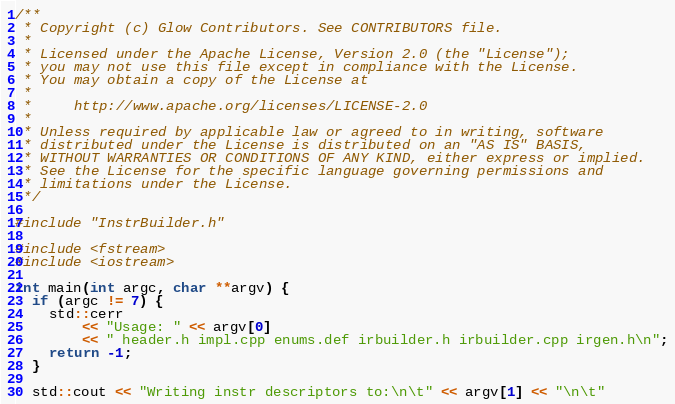Convert code to text. <code><loc_0><loc_0><loc_500><loc_500><_C++_>/**
 * Copyright (c) Glow Contributors. See CONTRIBUTORS file.
 *
 * Licensed under the Apache License, Version 2.0 (the "License");
 * you may not use this file except in compliance with the License.
 * You may obtain a copy of the License at
 *
 *     http://www.apache.org/licenses/LICENSE-2.0
 *
 * Unless required by applicable law or agreed to in writing, software
 * distributed under the License is distributed on an "AS IS" BASIS,
 * WITHOUT WARRANTIES OR CONDITIONS OF ANY KIND, either express or implied.
 * See the License for the specific language governing permissions and
 * limitations under the License.
 */

#include "InstrBuilder.h"

#include <fstream>
#include <iostream>

int main(int argc, char **argv) {
  if (argc != 7) {
    std::cerr
        << "Usage: " << argv[0]
        << " header.h impl.cpp enums.def irbuilder.h irbuilder.cpp irgen.h\n";
    return -1;
  }

  std::cout << "Writing instr descriptors to:\n\t" << argv[1] << "\n\t"</code> 